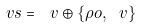<formula> <loc_0><loc_0><loc_500><loc_500>\ v s = \ v \oplus \{ \rho o , \ v \}</formula> 